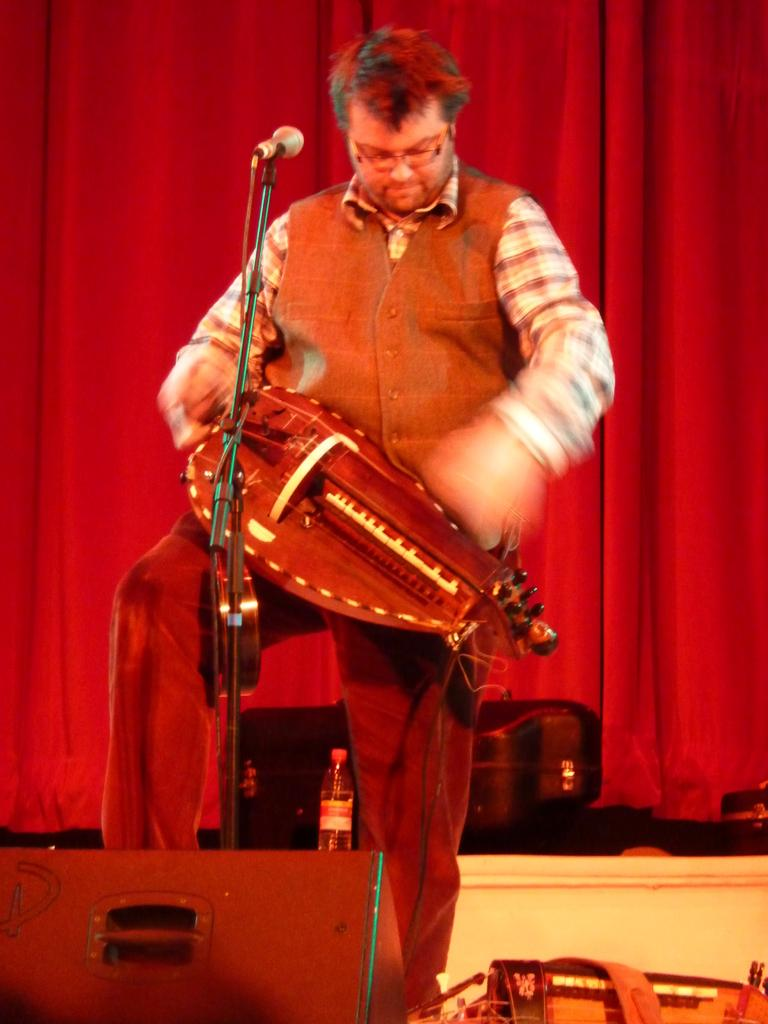Who is the main subject in the image? There is a man in the middle of the image. What is the man doing in the image? The man is standing in front of a microphone and holding a musical instrument. What can be seen behind the man? There is a bottle visible behind the man, and there are curtains behind him as well. How many oranges are on the faucet in the image? There are no oranges or faucets present in the image. What type of event is taking place in the image? The image does not provide enough information to determine the type of event that might be taking place. 